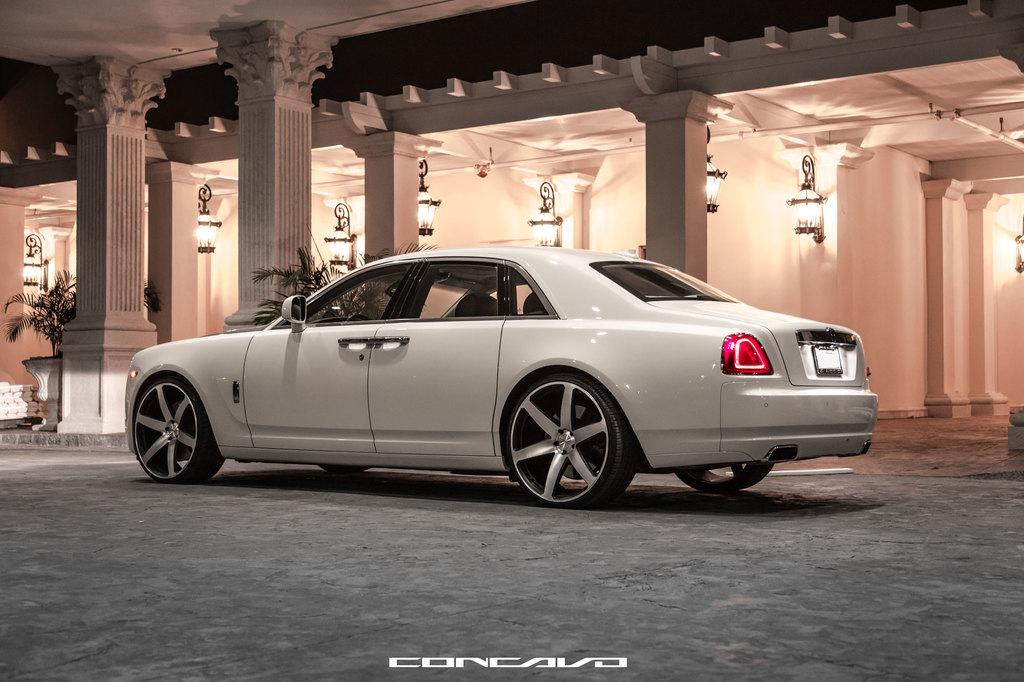What is the main subject of the image? There is a car on the road in the image. What can be seen in the background of the image? There is a building in the background of the image. What architectural features are visible in the image? There are pillars visible in the image. What type of illumination is present in the image? There are lights in the image. What time of day is it in the image, given that it's morning? The provided facts do not mention the time of day, and there is no indication of morning in the image. 